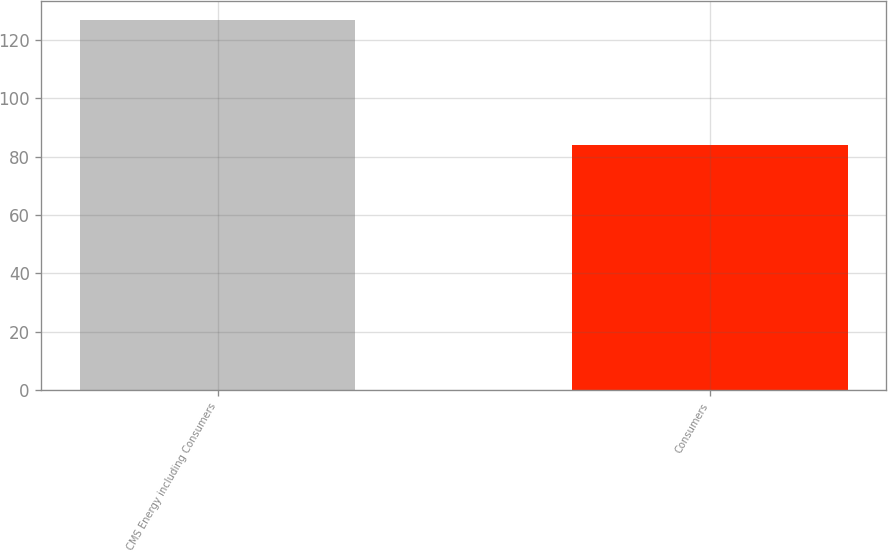<chart> <loc_0><loc_0><loc_500><loc_500><bar_chart><fcel>CMS Energy including Consumers<fcel>Consumers<nl><fcel>127<fcel>84<nl></chart> 